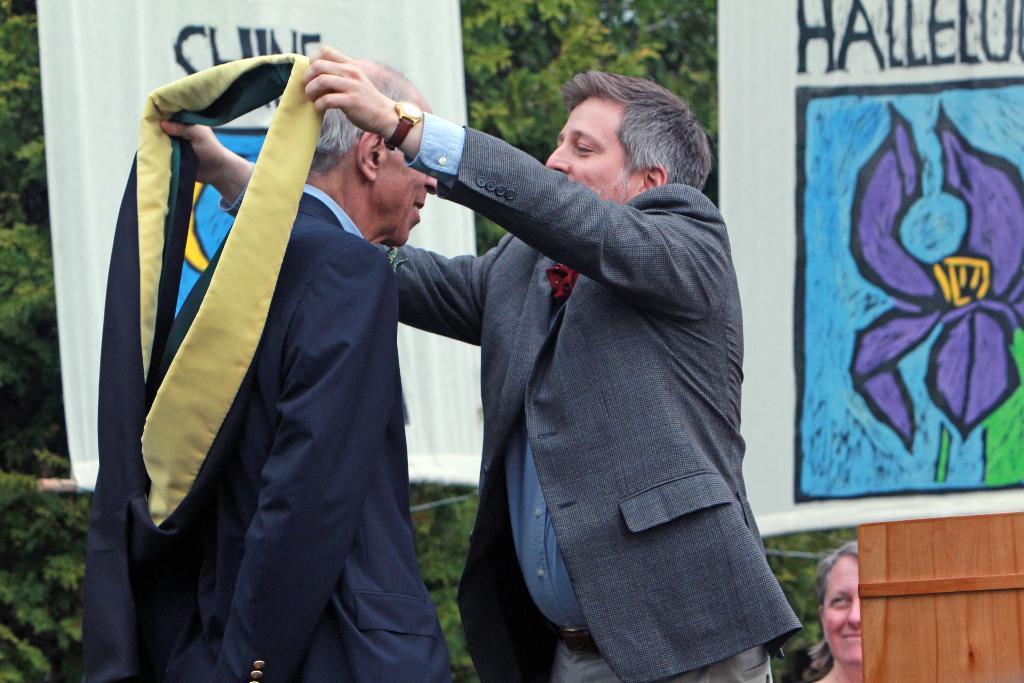Could you give a brief overview of what you see in this image? In this image, we can see two men standing, we can see posters and there is a woman, we can see some plants and trees. 